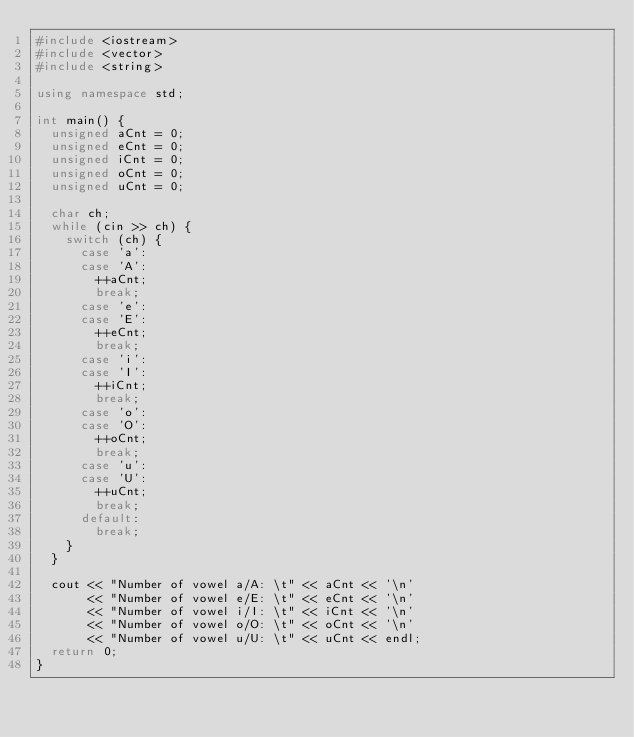<code> <loc_0><loc_0><loc_500><loc_500><_C++_>#include <iostream>
#include <vector>
#include <string>

using namespace std;

int main() {
  unsigned aCnt = 0;
  unsigned eCnt = 0;
  unsigned iCnt = 0;
  unsigned oCnt = 0;
  unsigned uCnt = 0;

  char ch;
  while (cin >> ch) {
    switch (ch) {
      case 'a':
      case 'A':
        ++aCnt;
        break;
      case 'e':
      case 'E':
        ++eCnt;
        break;
      case 'i':
      case 'I':
        ++iCnt;
        break;
      case 'o':
      case 'O':
        ++oCnt;
        break;
      case 'u':
      case 'U':
        ++uCnt;
        break;
      default:
        break;
    }
  }

  cout << "Number of vowel a/A: \t" << aCnt << '\n'
       << "Number of vowel e/E: \t" << eCnt << '\n'
       << "Number of vowel i/I: \t" << iCnt << '\n'
       << "Number of vowel o/O: \t" << oCnt << '\n'
       << "Number of vowel u/U: \t" << uCnt << endl;
  return 0;
}



</code> 